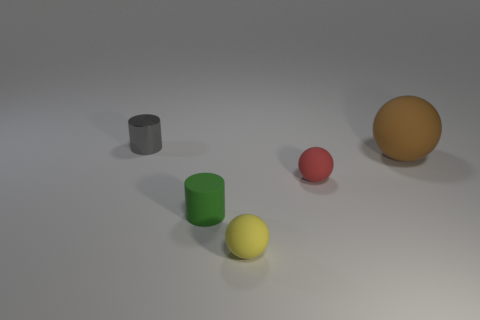Subtract all big brown spheres. How many spheres are left? 2 Subtract 1 spheres. How many spheres are left? 2 Add 3 big objects. How many objects exist? 8 Subtract all balls. How many objects are left? 2 Subtract all brown matte things. Subtract all tiny red spheres. How many objects are left? 3 Add 1 small metallic objects. How many small metallic objects are left? 2 Add 1 green cylinders. How many green cylinders exist? 2 Subtract 1 yellow spheres. How many objects are left? 4 Subtract all yellow cylinders. Subtract all blue blocks. How many cylinders are left? 2 